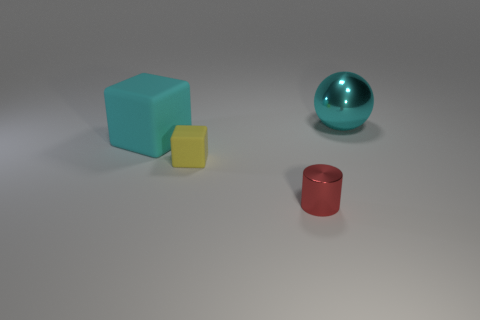Add 4 cyan shiny spheres. How many objects exist? 8 Subtract 1 blocks. How many blocks are left? 1 Subtract all yellow cubes. How many cubes are left? 1 Subtract all red cylinders. How many yellow blocks are left? 1 Subtract 1 cyan cubes. How many objects are left? 3 Subtract all yellow cylinders. Subtract all green blocks. How many cylinders are left? 1 Subtract all big cyan things. Subtract all tiny red cylinders. How many objects are left? 1 Add 1 red cylinders. How many red cylinders are left? 2 Add 2 cyan metal cylinders. How many cyan metal cylinders exist? 2 